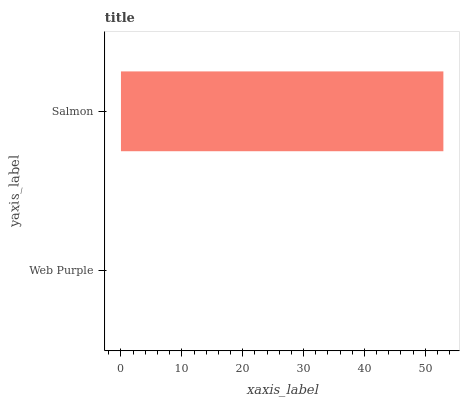Is Web Purple the minimum?
Answer yes or no. Yes. Is Salmon the maximum?
Answer yes or no. Yes. Is Salmon the minimum?
Answer yes or no. No. Is Salmon greater than Web Purple?
Answer yes or no. Yes. Is Web Purple less than Salmon?
Answer yes or no. Yes. Is Web Purple greater than Salmon?
Answer yes or no. No. Is Salmon less than Web Purple?
Answer yes or no. No. Is Salmon the high median?
Answer yes or no. Yes. Is Web Purple the low median?
Answer yes or no. Yes. Is Web Purple the high median?
Answer yes or no. No. Is Salmon the low median?
Answer yes or no. No. 